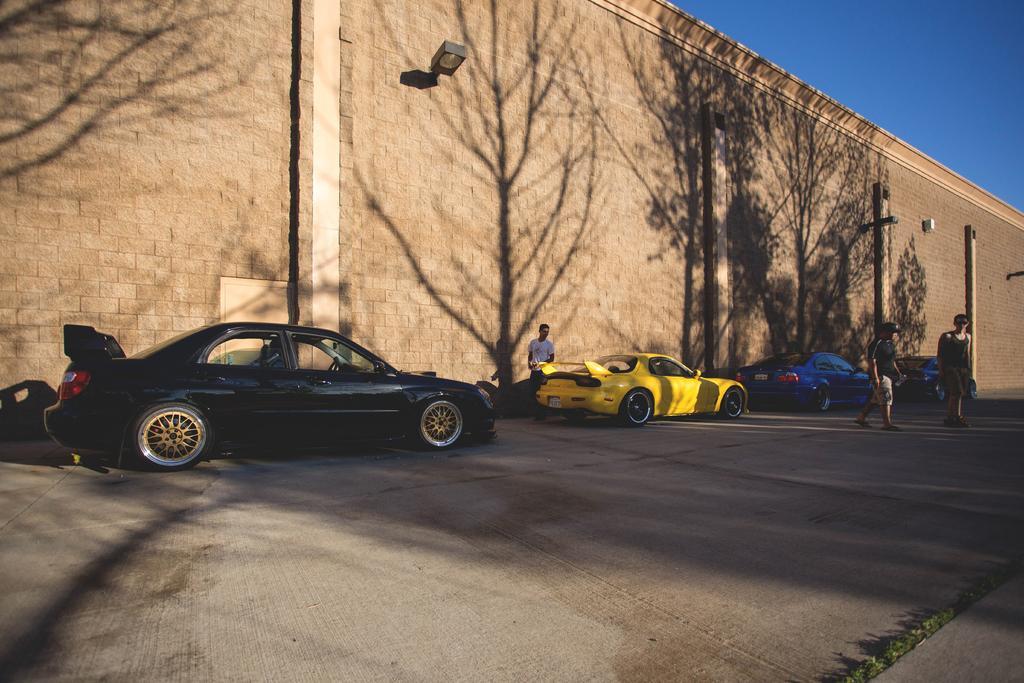In one or two sentences, can you explain what this image depicts? In this picture, we can see the road, a few people, vehicles, and we can see some plants, wall with some objects attached to it like lights, pipes, and we can see reflections of trees on the wall, and we can see the sky. 